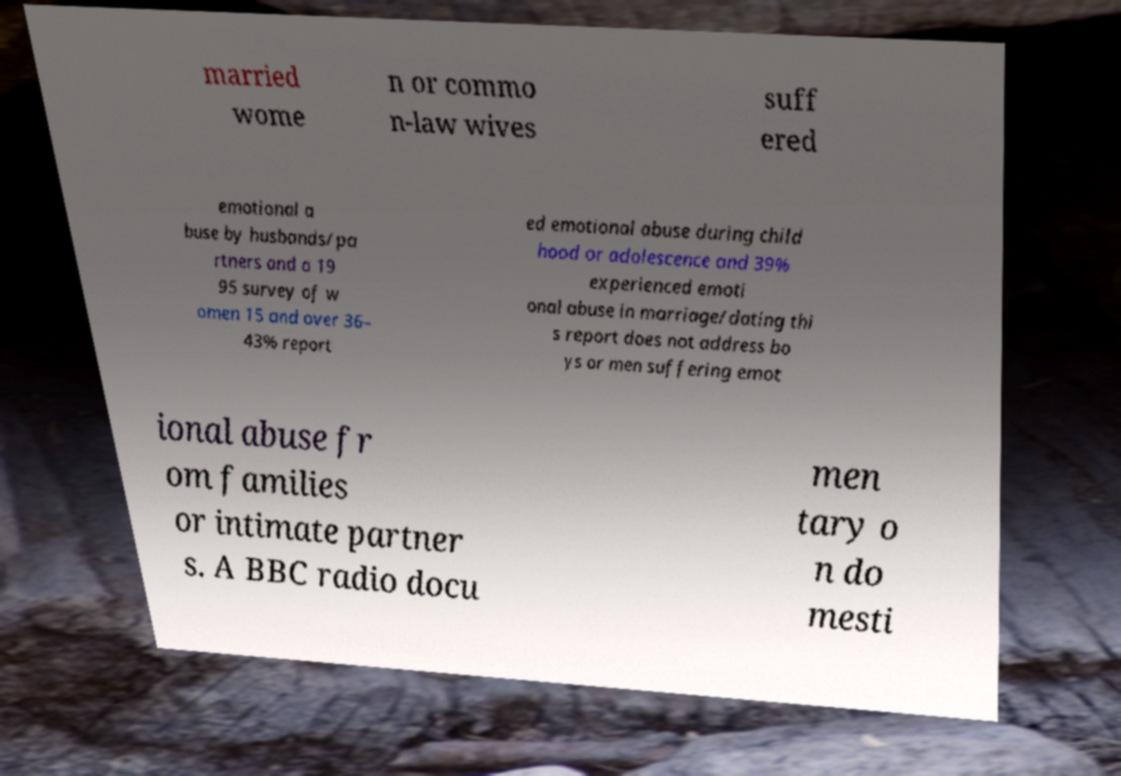For documentation purposes, I need the text within this image transcribed. Could you provide that? married wome n or commo n-law wives suff ered emotional a buse by husbands/pa rtners and a 19 95 survey of w omen 15 and over 36– 43% report ed emotional abuse during child hood or adolescence and 39% experienced emoti onal abuse in marriage/dating thi s report does not address bo ys or men suffering emot ional abuse fr om families or intimate partner s. A BBC radio docu men tary o n do mesti 